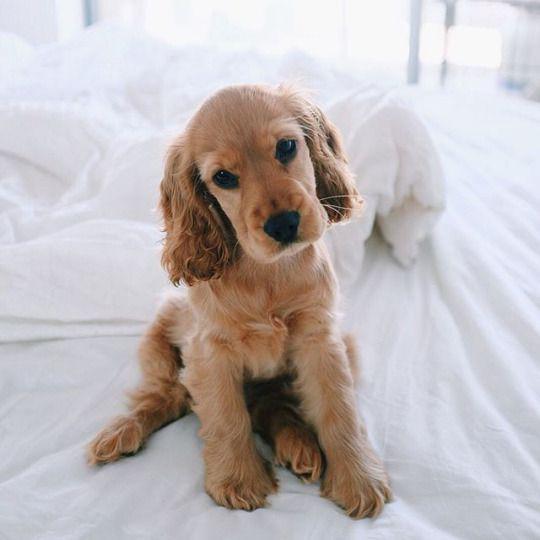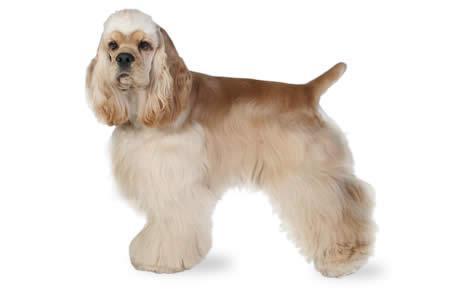The first image is the image on the left, the second image is the image on the right. Given the left and right images, does the statement "Together, the two images show a puppy and a full-grown spaniel." hold true? Answer yes or no. Yes. 